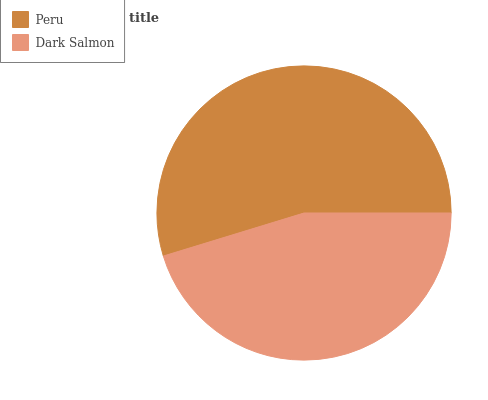Is Dark Salmon the minimum?
Answer yes or no. Yes. Is Peru the maximum?
Answer yes or no. Yes. Is Dark Salmon the maximum?
Answer yes or no. No. Is Peru greater than Dark Salmon?
Answer yes or no. Yes. Is Dark Salmon less than Peru?
Answer yes or no. Yes. Is Dark Salmon greater than Peru?
Answer yes or no. No. Is Peru less than Dark Salmon?
Answer yes or no. No. Is Peru the high median?
Answer yes or no. Yes. Is Dark Salmon the low median?
Answer yes or no. Yes. Is Dark Salmon the high median?
Answer yes or no. No. Is Peru the low median?
Answer yes or no. No. 